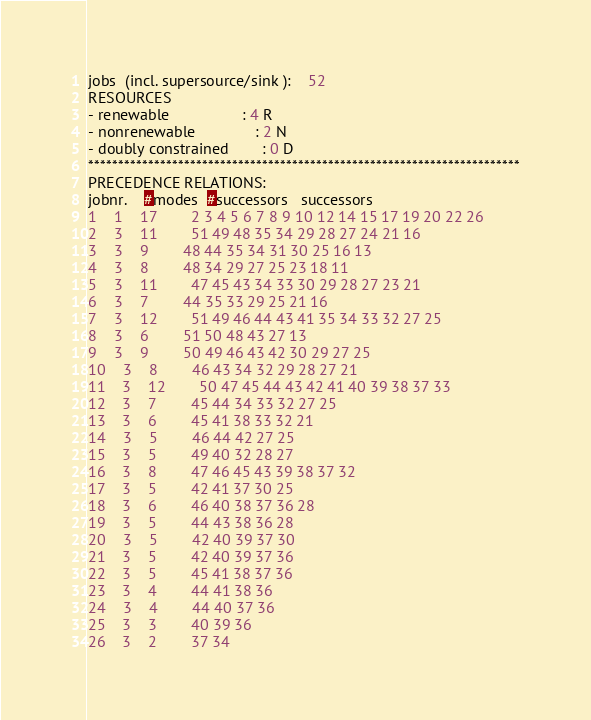<code> <loc_0><loc_0><loc_500><loc_500><_ObjectiveC_>jobs  (incl. supersource/sink ):	52
RESOURCES
- renewable                 : 4 R
- nonrenewable              : 2 N
- doubly constrained        : 0 D
************************************************************************
PRECEDENCE RELATIONS:
jobnr.    #modes  #successors   successors
1	1	17		2 3 4 5 6 7 8 9 10 12 14 15 17 19 20 22 26 
2	3	11		51 49 48 35 34 29 28 27 24 21 16 
3	3	9		48 44 35 34 31 30 25 16 13 
4	3	8		48 34 29 27 25 23 18 11 
5	3	11		47 45 43 34 33 30 29 28 27 23 21 
6	3	7		44 35 33 29 25 21 16 
7	3	12		51 49 46 44 43 41 35 34 33 32 27 25 
8	3	6		51 50 48 43 27 13 
9	3	9		50 49 46 43 42 30 29 27 25 
10	3	8		46 43 34 32 29 28 27 21 
11	3	12		50 47 45 44 43 42 41 40 39 38 37 33 
12	3	7		45 44 34 33 32 27 25 
13	3	6		45 41 38 33 32 21 
14	3	5		46 44 42 27 25 
15	3	5		49 40 32 28 27 
16	3	8		47 46 45 43 39 38 37 32 
17	3	5		42 41 37 30 25 
18	3	6		46 40 38 37 36 28 
19	3	5		44 43 38 36 28 
20	3	5		42 40 39 37 30 
21	3	5		42 40 39 37 36 
22	3	5		45 41 38 37 36 
23	3	4		44 41 38 36 
24	3	4		44 40 37 36 
25	3	3		40 39 36 
26	3	2		37 34 </code> 